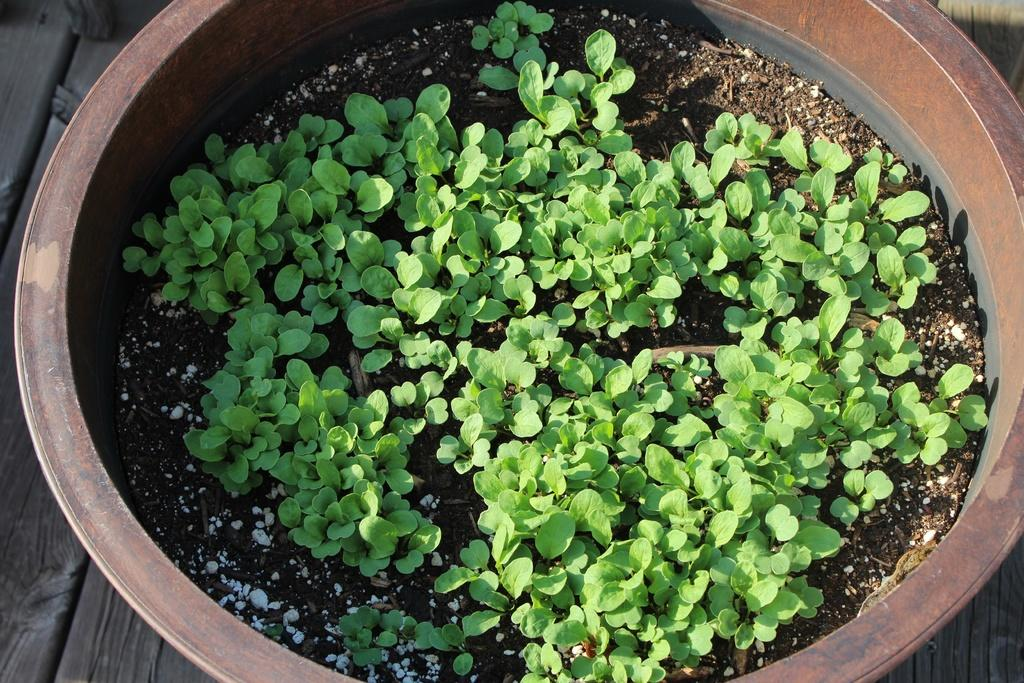What is inside the pot in the image? There are plants in the pot. What is used to support the growth of the plants in the pot? There is soil in the pot. What is the pot resting on in the image? The pot is on a wooden object. How many oranges are hanging from the plants in the image? There are no oranges present in the image; it only features plants and soil in a pot. 